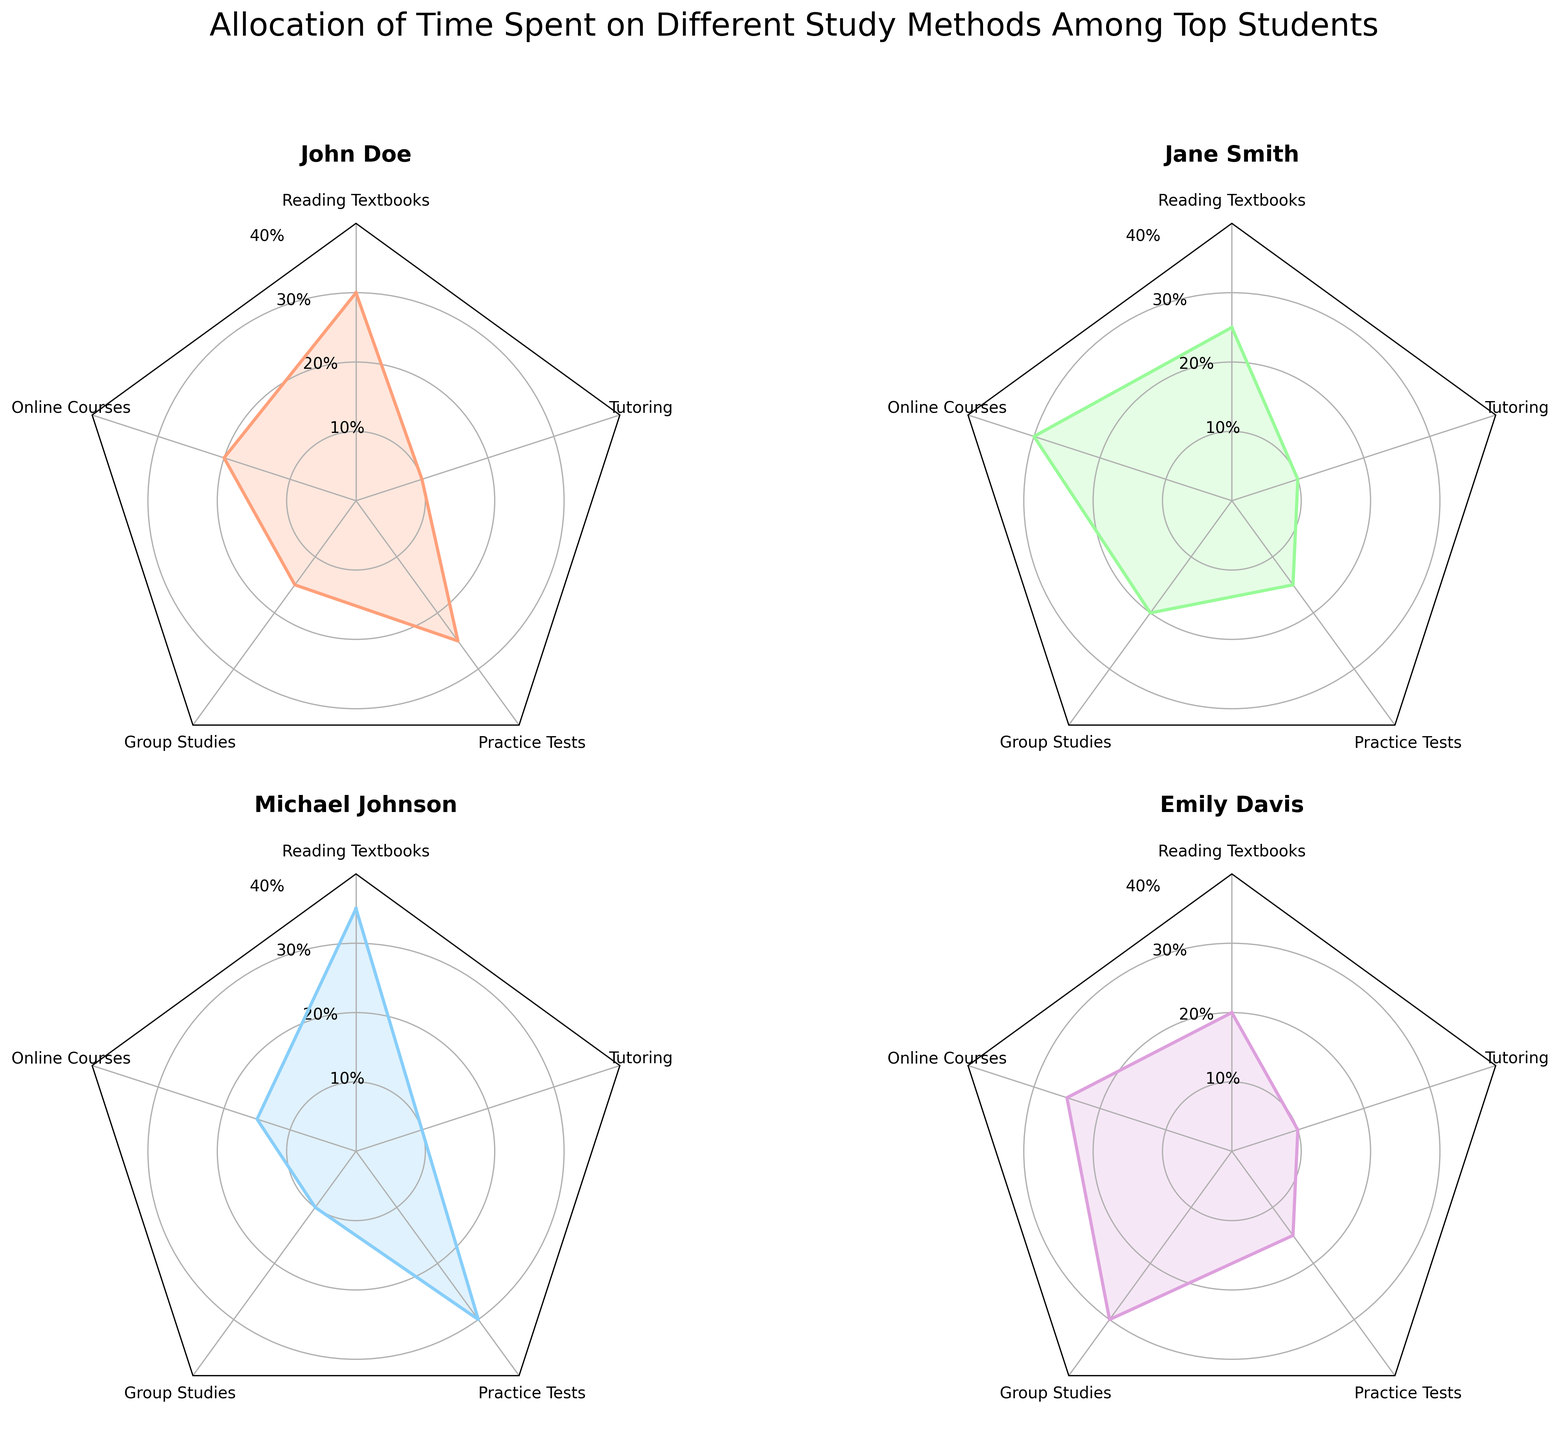What is the title of the figure? The title of the figure is always found at the top of the plot, usually in a larger font. In this case, it reads "Allocation of Time Spent on Different Study Methods Among Top Students."
Answer: Allocation of Time Spent on Different Study Methods Among Top Students Which study method does John Doe spend the most time on? To find this, examine the data points for John Doe and identify the highest value by checking the axes labels. The value for Practice Tests (0.25) is the highest.
Answer: Practice Tests Which student spends the most time on group studies? Compare the data points for Group Studies across all four students' radar charts. Emily Davis has the highest value at 0.3.
Answer: Emily Davis What is the total proportion of time Michael Johnson spends on Reading Textbooks and Practice Tests? Add up the values for Reading Textbooks (0.35) and Practice Tests (0.30). 0.35 + 0.30 = 0.65
Answer: 0.65 How does Jane Smith's time spent on Online Courses compare to John Doe's? Look at the Online Courses values for Jane Smith (0.3) and John Doe (0.2). Jane Smith spends 0.1 more time than John Doe.
Answer: Jane Smith spends 0.1 more Which study method has the most uniform time allocation among the students? Examine each study method's values across all students and find the one with the least variation. Tutoring has the same value (0.1) for all students.
Answer: Tutoring What is the average time spent on Group Studies by all students? Sum the values for Group Studies (0.15 + 0.2 + 0.1 + 0.3) and divide by 4. (0.15 + 0.2 + 0.1 + 0.3) / 4 = 0.1875
Answer: 0.1875 Which student allocates the least time to Practice Tests? Compare the Practice Tests values and find the lowest. Jane Smith spends the least time, with a value of 0.15.
Answer: Jane Smith 